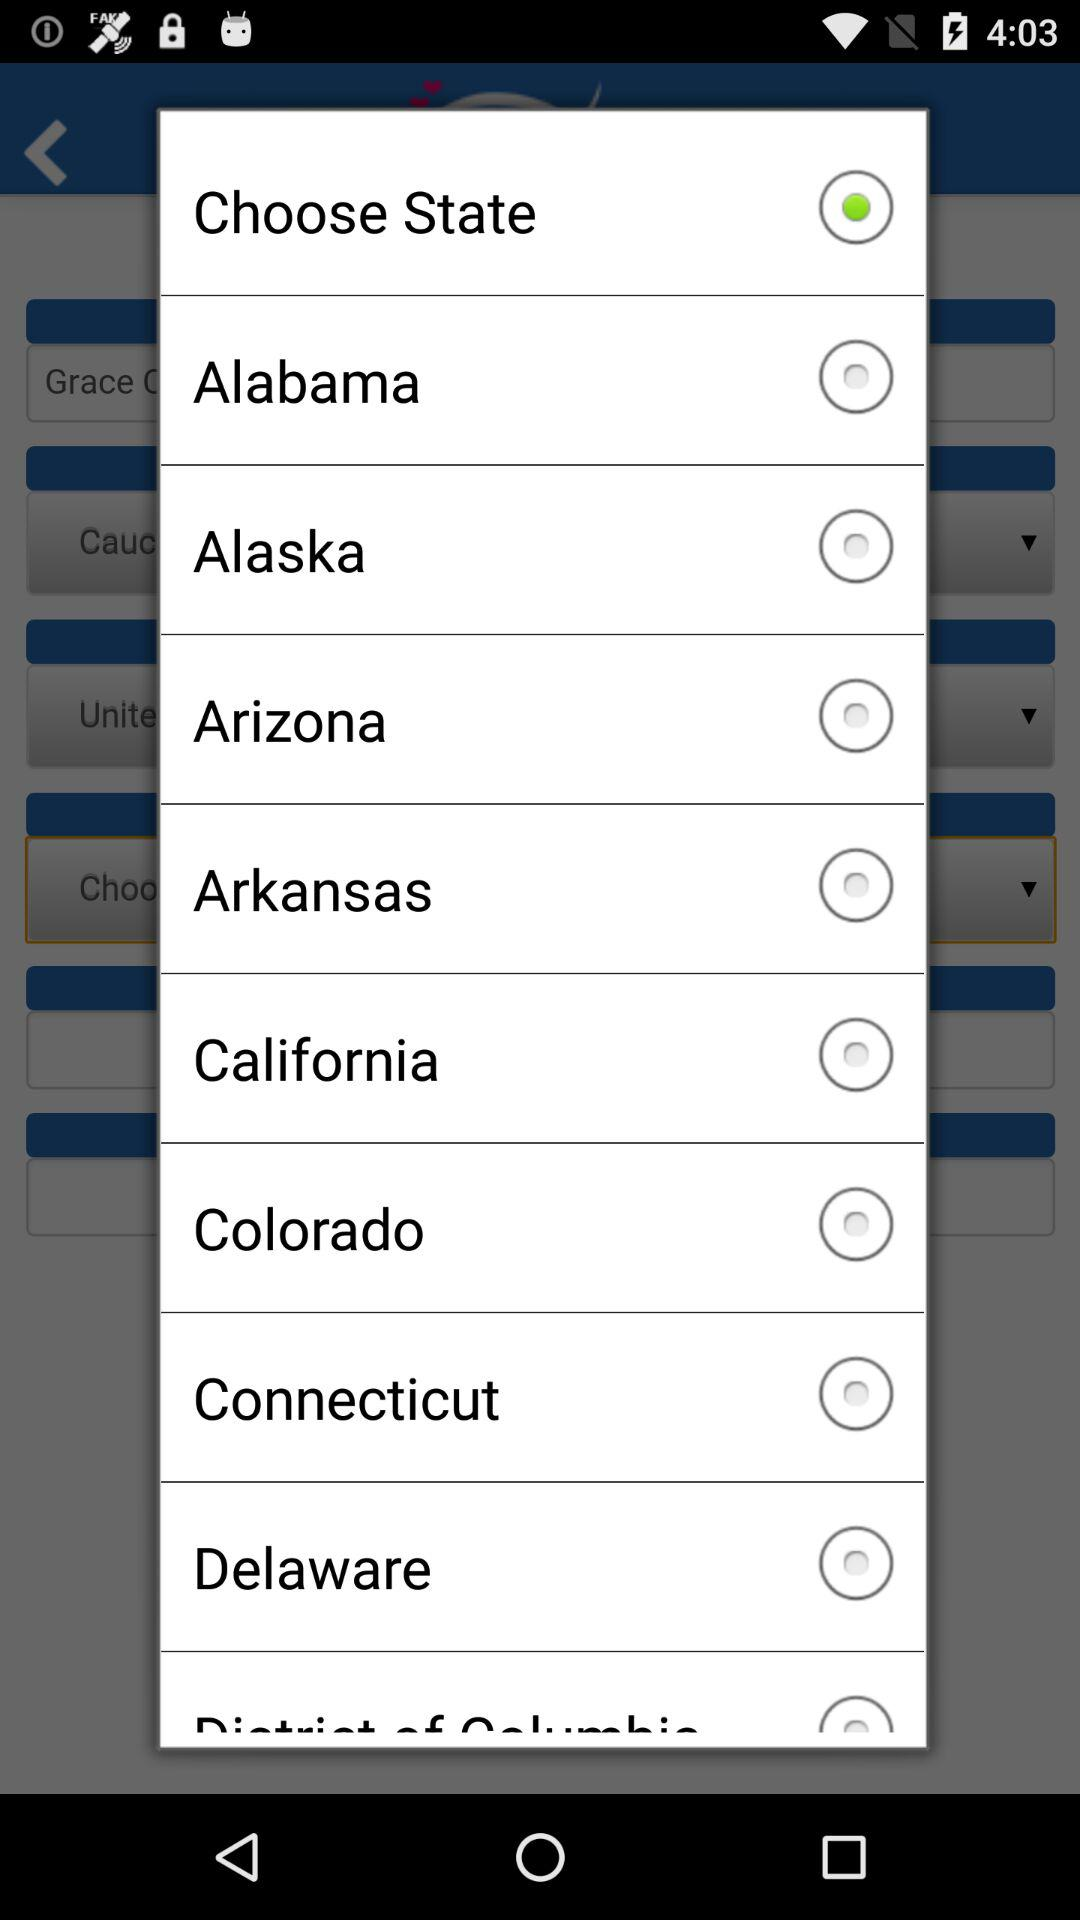What are the available options? The available options are "Alabama", "Alaska", "Arizona", "Arkansas", "California", "Colorado", "Connecticut" and "Delaware". 